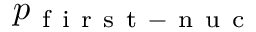<formula> <loc_0><loc_0><loc_500><loc_500>p _ { f i r s t - n u c }</formula> 